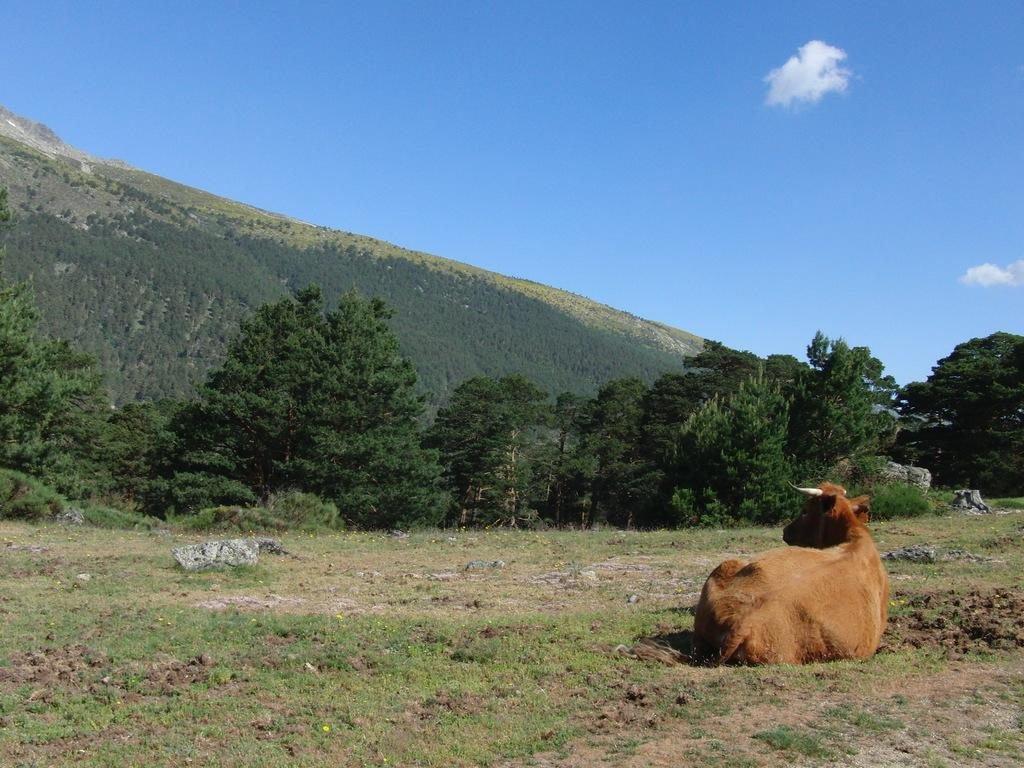What animal can be seen in the picture? There is a cow in the picture. What type of vegetation is present in the picture? There are trees in the picture. What geographical feature is visible in the picture? There is a hill in the picture. What type of natural objects can be seen in the picture? There are rocks in the picture. How would you describe the sky in the picture? The sky is blue and cloudy. Can you see the cow's elbow in the picture? There is no visible elbow on the cow in the picture, as cows do not have elbows like humans. 